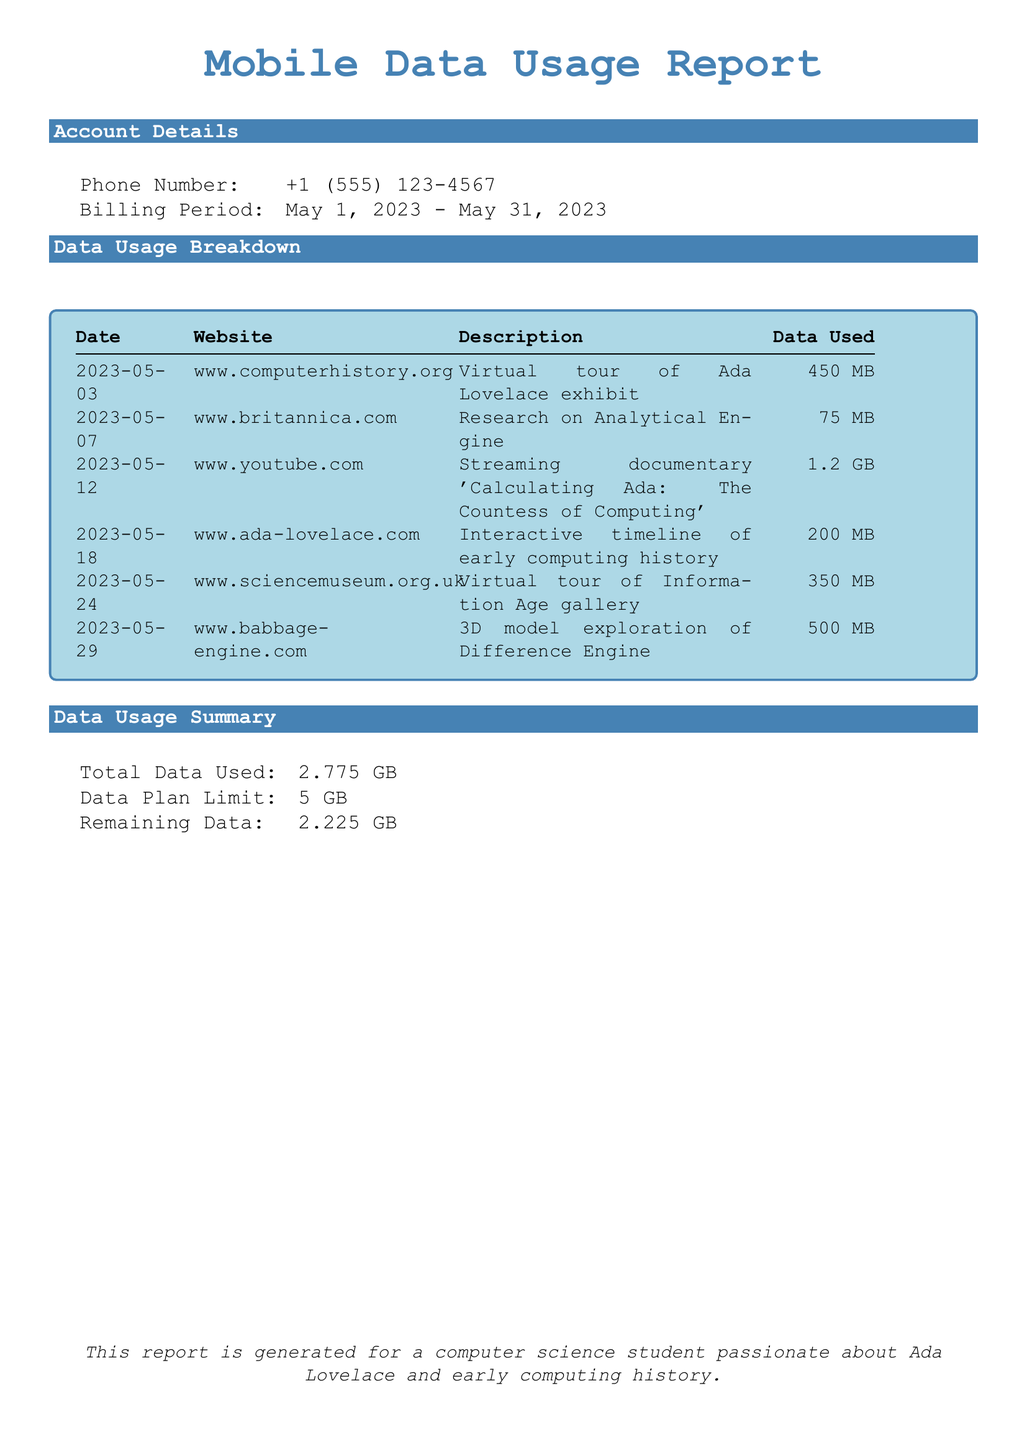what is the phone number? The phone number listed in the account details section of the document is recorded.
Answer: +1 (555) 123-4567 what is the billing period? The billing period is specified in the account details section, covering a full month.
Answer: May 1, 2023 - May 31, 2023 what was the data usage for the virtual tour of Ada Lovelace exhibit? The specific data usage for the Ada Lovelace virtual tour is mentioned in the data usage breakdown.
Answer: 450 MB which website was used for the interactive timeline of early computing history? The website name is found in the data usage breakdown corresponding to the interactive timeline.
Answer: www.ada-lovelace.com how much total data was used during the billing period? The total data used is calculated and stated in the document’s summary.
Answer: 2.775 GB which streaming documentary was watched on YouTube? The name of the documentary is provided in the description column of the data usage breakdown.
Answer: Calculating Ada: The Countess of Computing what is the remaining data after the billing period? The remaining data is calculated and listed in the summary section of the document.
Answer: 2.225 GB what is the data plan limit? The limit of the data plan is explicitly stated in the summary section of the report.
Answer: 5 GB which date had the highest data usage? By evaluating the data usage breakdown, the date with the highest usage can be determined.
Answer: 2023-05-12 